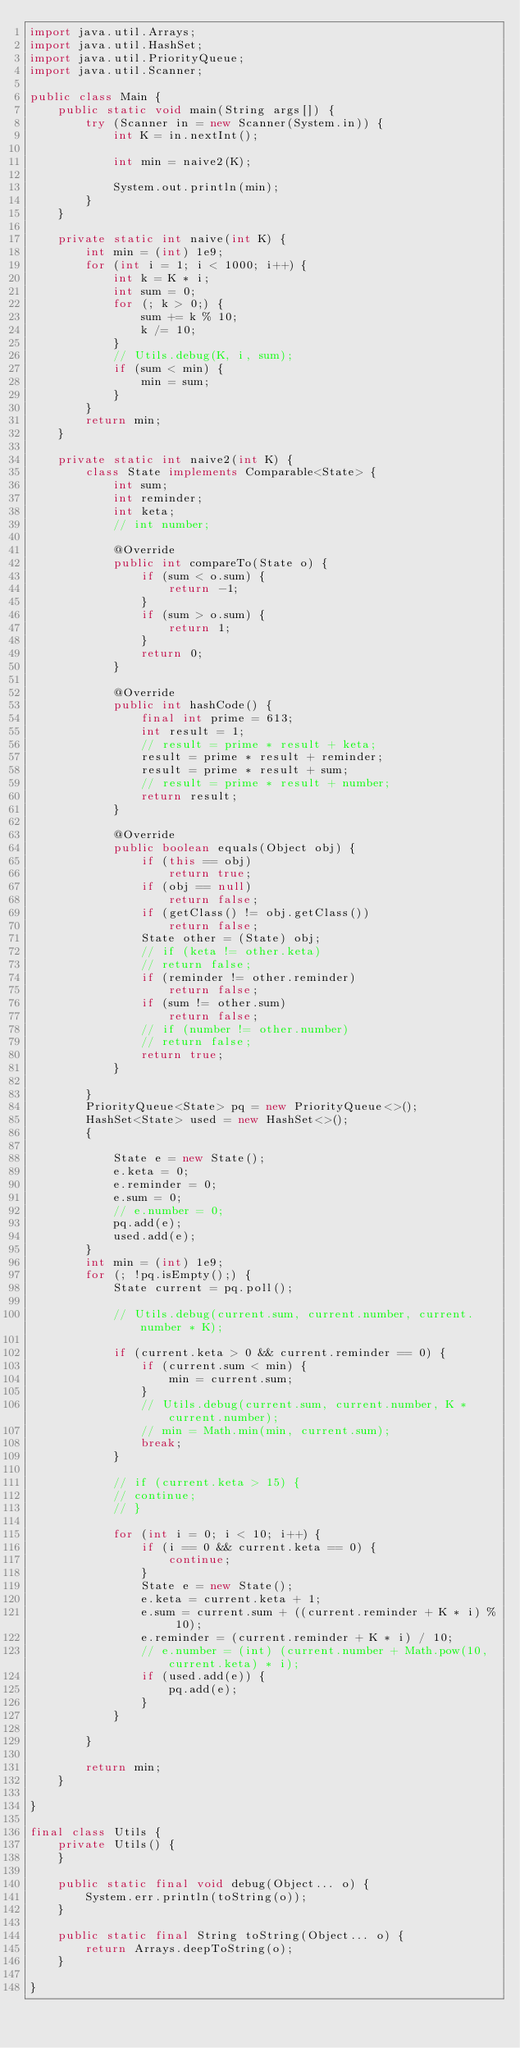Convert code to text. <code><loc_0><loc_0><loc_500><loc_500><_Java_>import java.util.Arrays;
import java.util.HashSet;
import java.util.PriorityQueue;
import java.util.Scanner;

public class Main {
    public static void main(String args[]) {
        try (Scanner in = new Scanner(System.in)) {
            int K = in.nextInt();

            int min = naive2(K);

            System.out.println(min);
        }
    }

    private static int naive(int K) {
        int min = (int) 1e9;
        for (int i = 1; i < 1000; i++) {
            int k = K * i;
            int sum = 0;
            for (; k > 0;) {
                sum += k % 10;
                k /= 10;
            }
            // Utils.debug(K, i, sum);
            if (sum < min) {
                min = sum;
            }
        }
        return min;
    }

    private static int naive2(int K) {
        class State implements Comparable<State> {
            int sum;
            int reminder;
            int keta;
            // int number;

            @Override
            public int compareTo(State o) {
                if (sum < o.sum) {
                    return -1;
                }
                if (sum > o.sum) {
                    return 1;
                }
                return 0;
            }

            @Override
            public int hashCode() {
                final int prime = 613;
                int result = 1;
                // result = prime * result + keta;
                result = prime * result + reminder;
                result = prime * result + sum;
                // result = prime * result + number;
                return result;
            }

            @Override
            public boolean equals(Object obj) {
                if (this == obj)
                    return true;
                if (obj == null)
                    return false;
                if (getClass() != obj.getClass())
                    return false;
                State other = (State) obj;
                // if (keta != other.keta)
                // return false;
                if (reminder != other.reminder)
                    return false;
                if (sum != other.sum)
                    return false;
                // if (number != other.number)
                // return false;
                return true;
            }

        }
        PriorityQueue<State> pq = new PriorityQueue<>();
        HashSet<State> used = new HashSet<>();
        {

            State e = new State();
            e.keta = 0;
            e.reminder = 0;
            e.sum = 0;
            // e.number = 0;
            pq.add(e);
            used.add(e);
        }
        int min = (int) 1e9;
        for (; !pq.isEmpty();) {
            State current = pq.poll();

            // Utils.debug(current.sum, current.number, current.number * K);

            if (current.keta > 0 && current.reminder == 0) {
                if (current.sum < min) {
                    min = current.sum;
                }
                // Utils.debug(current.sum, current.number, K * current.number);
                // min = Math.min(min, current.sum);
                break;
            }

            // if (current.keta > 15) {
            // continue;
            // }

            for (int i = 0; i < 10; i++) {
                if (i == 0 && current.keta == 0) {
                    continue;
                }
                State e = new State();
                e.keta = current.keta + 1;
                e.sum = current.sum + ((current.reminder + K * i) % 10);
                e.reminder = (current.reminder + K * i) / 10;
                // e.number = (int) (current.number + Math.pow(10, current.keta) * i);
                if (used.add(e)) {
                    pq.add(e);
                }
            }

        }

        return min;
    }

}

final class Utils {
    private Utils() {
    }

    public static final void debug(Object... o) {
        System.err.println(toString(o));
    }

    public static final String toString(Object... o) {
        return Arrays.deepToString(o);
    }

}
</code> 